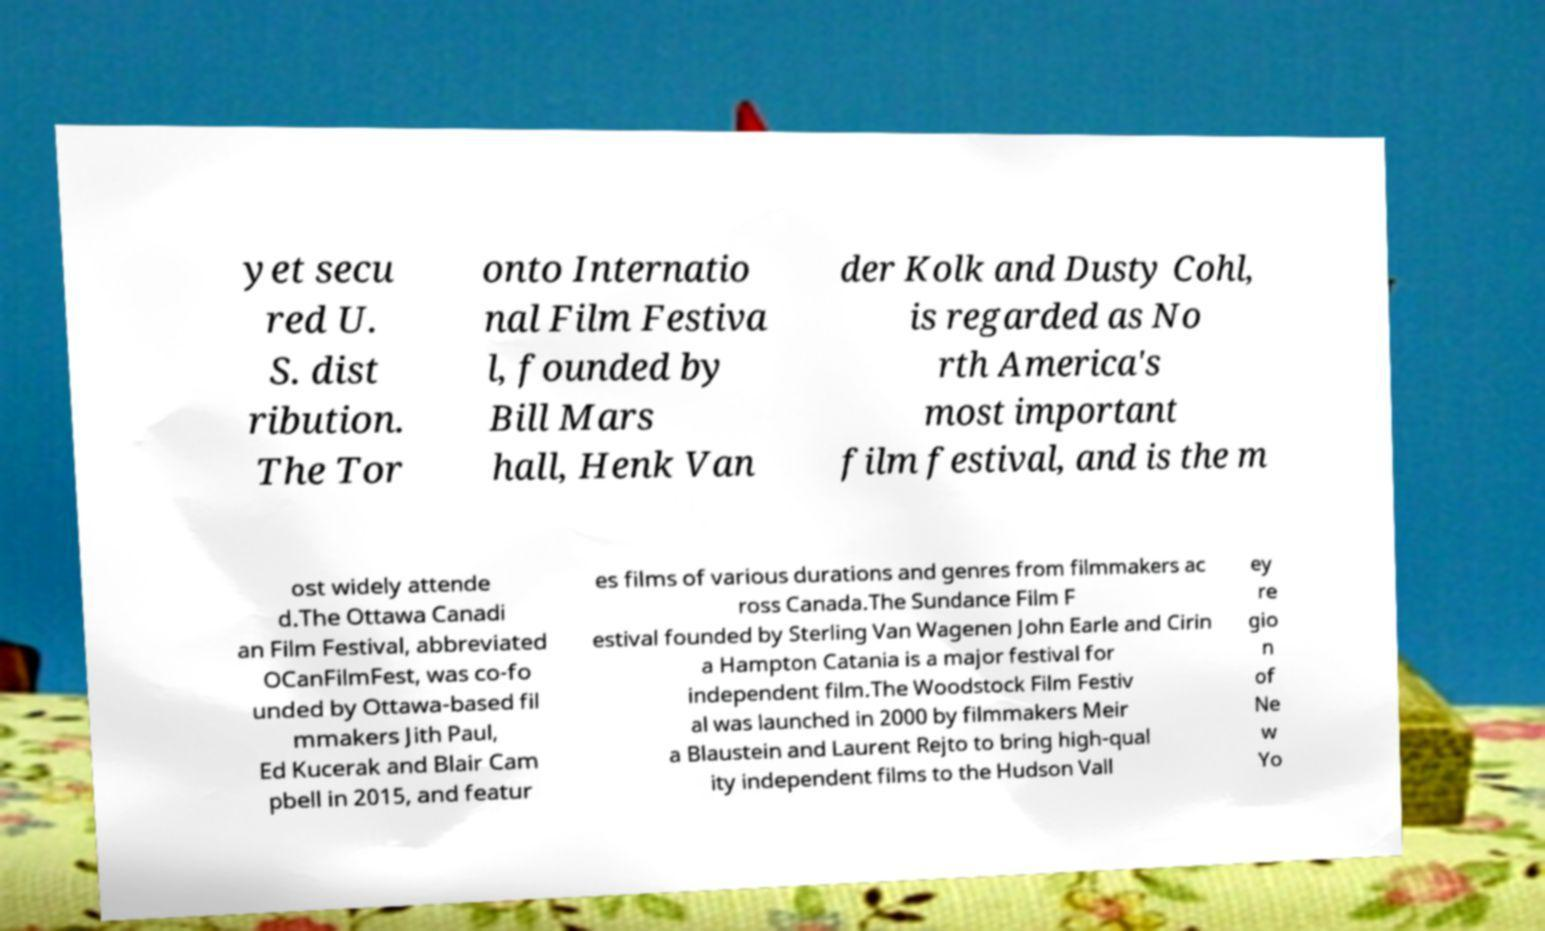For documentation purposes, I need the text within this image transcribed. Could you provide that? yet secu red U. S. dist ribution. The Tor onto Internatio nal Film Festiva l, founded by Bill Mars hall, Henk Van der Kolk and Dusty Cohl, is regarded as No rth America's most important film festival, and is the m ost widely attende d.The Ottawa Canadi an Film Festival, abbreviated OCanFilmFest, was co-fo unded by Ottawa-based fil mmakers Jith Paul, Ed Kucerak and Blair Cam pbell in 2015, and featur es films of various durations and genres from filmmakers ac ross Canada.The Sundance Film F estival founded by Sterling Van Wagenen John Earle and Cirin a Hampton Catania is a major festival for independent film.The Woodstock Film Festiv al was launched in 2000 by filmmakers Meir a Blaustein and Laurent Rejto to bring high-qual ity independent films to the Hudson Vall ey re gio n of Ne w Yo 